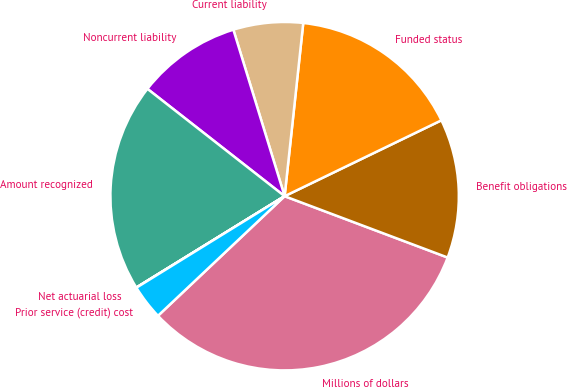Convert chart to OTSL. <chart><loc_0><loc_0><loc_500><loc_500><pie_chart><fcel>Millions of dollars<fcel>Benefit obligations<fcel>Funded status<fcel>Current liability<fcel>Noncurrent liability<fcel>Amount recognized<fcel>Net actuarial loss<fcel>Prior service (credit) cost<nl><fcel>32.23%<fcel>12.9%<fcel>16.12%<fcel>6.46%<fcel>9.68%<fcel>19.35%<fcel>0.02%<fcel>3.24%<nl></chart> 